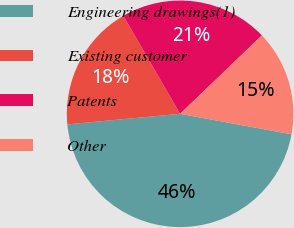Convert chart. <chart><loc_0><loc_0><loc_500><loc_500><pie_chart><fcel>Engineering drawings(1)<fcel>Existing customer<fcel>Patents<fcel>Other<nl><fcel>45.62%<fcel>18.13%<fcel>21.18%<fcel>15.07%<nl></chart> 